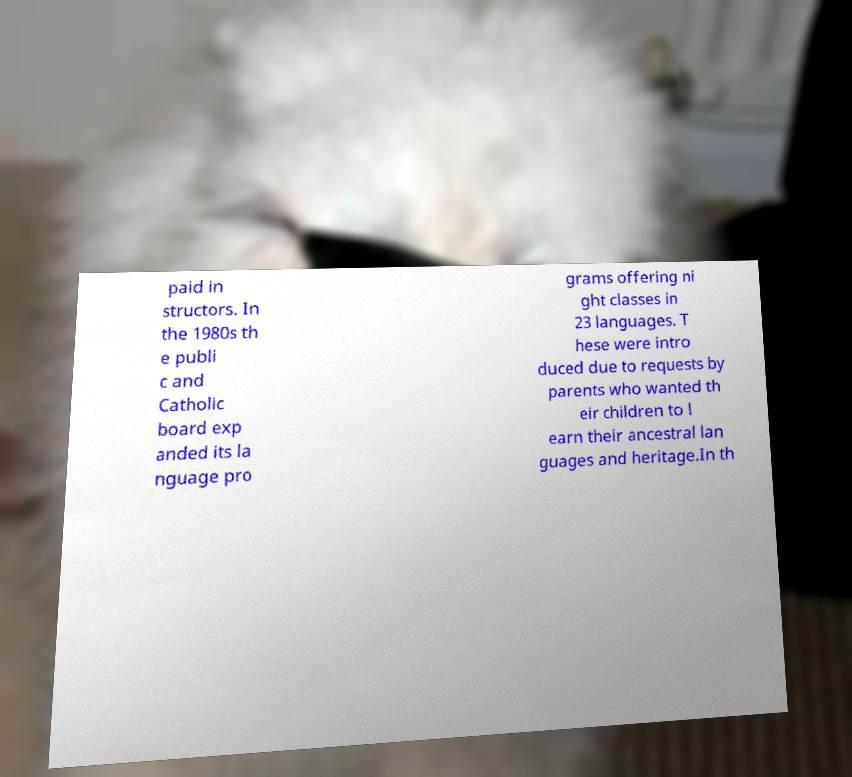Please identify and transcribe the text found in this image. paid in structors. In the 1980s th e publi c and Catholic board exp anded its la nguage pro grams offering ni ght classes in 23 languages. T hese were intro duced due to requests by parents who wanted th eir children to l earn their ancestral lan guages and heritage.In th 